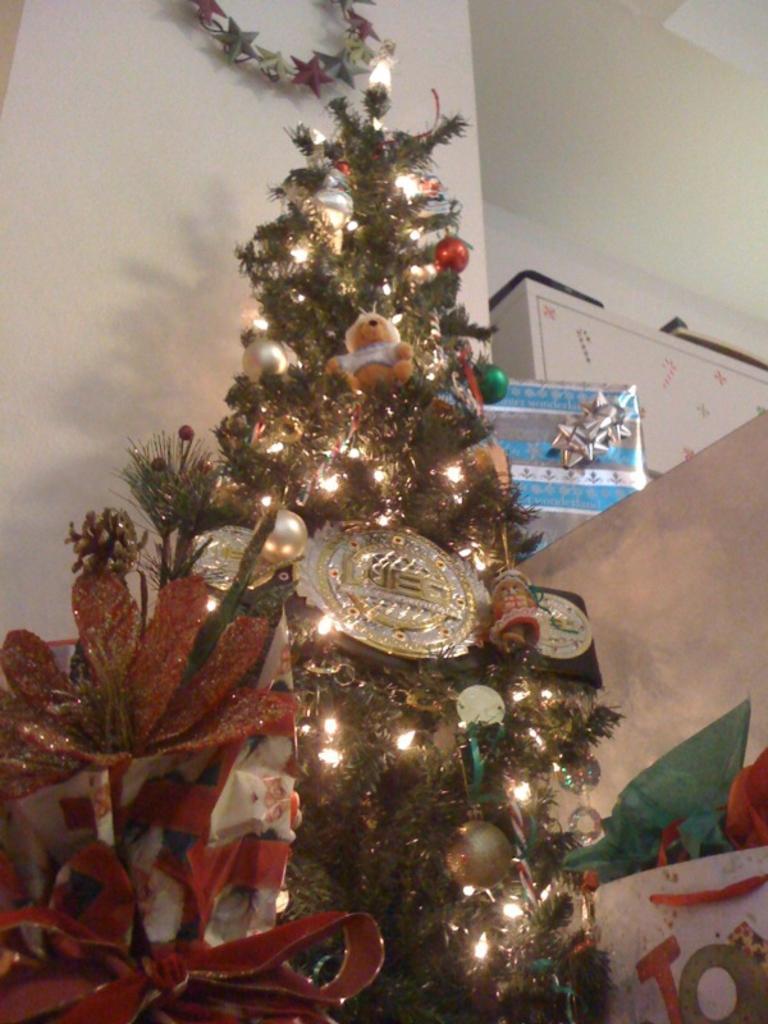Please provide a concise description of this image. In this picture we can see a Christmas tree with lights, decorative balls and in the background we can see a wall, boxes and some objects. 